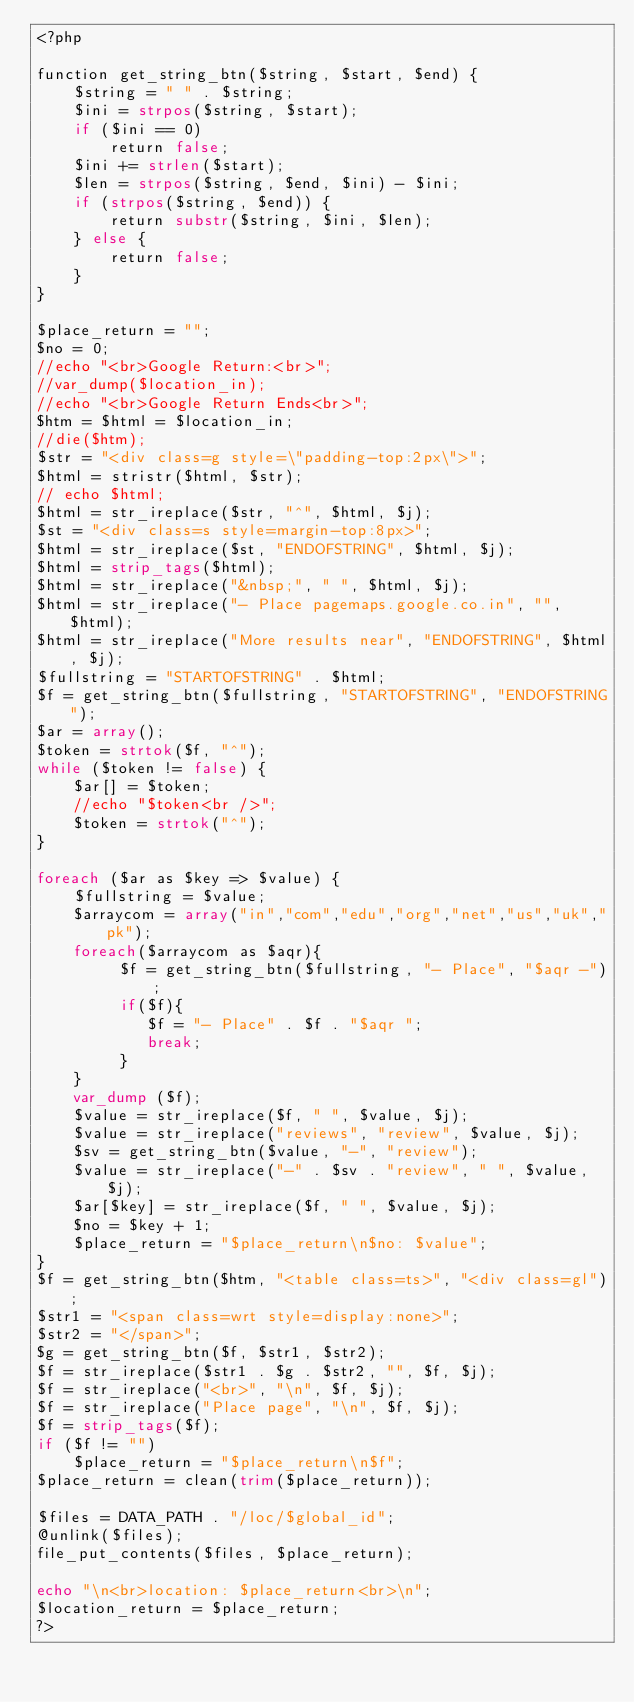<code> <loc_0><loc_0><loc_500><loc_500><_PHP_><?php

function get_string_btn($string, $start, $end) {
    $string = " " . $string;
    $ini = strpos($string, $start);
    if ($ini == 0)
        return false;
    $ini += strlen($start);
    $len = strpos($string, $end, $ini) - $ini;
    if (strpos($string, $end)) {
        return substr($string, $ini, $len);
    } else {
        return false;
    }
}

$place_return = "";
$no = 0;
//echo "<br>Google Return:<br>";
//var_dump($location_in);
//echo "<br>Google Return Ends<br>";
$htm = $html = $location_in;
//die($htm);
$str = "<div class=g style=\"padding-top:2px\">";
$html = stristr($html, $str);
// echo $html;
$html = str_ireplace($str, "^", $html, $j);
$st = "<div class=s style=margin-top:8px>";
$html = str_ireplace($st, "ENDOFSTRING", $html, $j);
$html = strip_tags($html);
$html = str_ireplace("&nbsp;", " ", $html, $j);
$html = str_ireplace("- Place pagemaps.google.co.in", "", $html);
$html = str_ireplace("More results near", "ENDOFSTRING", $html, $j);
$fullstring = "STARTOFSTRING" . $html;
$f = get_string_btn($fullstring, "STARTOFSTRING", "ENDOFSTRING");
$ar = array();
$token = strtok($f, "^");
while ($token != false) {
    $ar[] = $token;
    //echo "$token<br />";
    $token = strtok("^");
}

foreach ($ar as $key => $value) {
    $fullstring = $value;
    $arraycom = array("in","com","edu","org","net","us","uk","pk");
    foreach($arraycom as $aqr){
         $f = get_string_btn($fullstring, "- Place", "$aqr -");
         if($f){
            $f = "- Place" . $f . "$aqr ";
            break;
         }
    }
    var_dump ($f);
    $value = str_ireplace($f, " ", $value, $j);
    $value = str_ireplace("reviews", "review", $value, $j);
    $sv = get_string_btn($value, "-", "review");
    $value = str_ireplace("-" . $sv . "review", " ", $value, $j);
    $ar[$key] = str_ireplace($f, " ", $value, $j);
    $no = $key + 1;
    $place_return = "$place_return\n$no: $value";
}
$f = get_string_btn($htm, "<table class=ts>", "<div class=gl");
$str1 = "<span class=wrt style=display:none>";
$str2 = "</span>";
$g = get_string_btn($f, $str1, $str2);
$f = str_ireplace($str1 . $g . $str2, "", $f, $j);
$f = str_ireplace("<br>", "\n", $f, $j);
$f = str_ireplace("Place page", "\n", $f, $j);
$f = strip_tags($f);
if ($f != "")
    $place_return = "$place_return\n$f";
$place_return = clean(trim($place_return));

$files = DATA_PATH . "/loc/$global_id";
@unlink($files);
file_put_contents($files, $place_return);

echo "\n<br>location: $place_return<br>\n";
$location_return = $place_return;
?></code> 